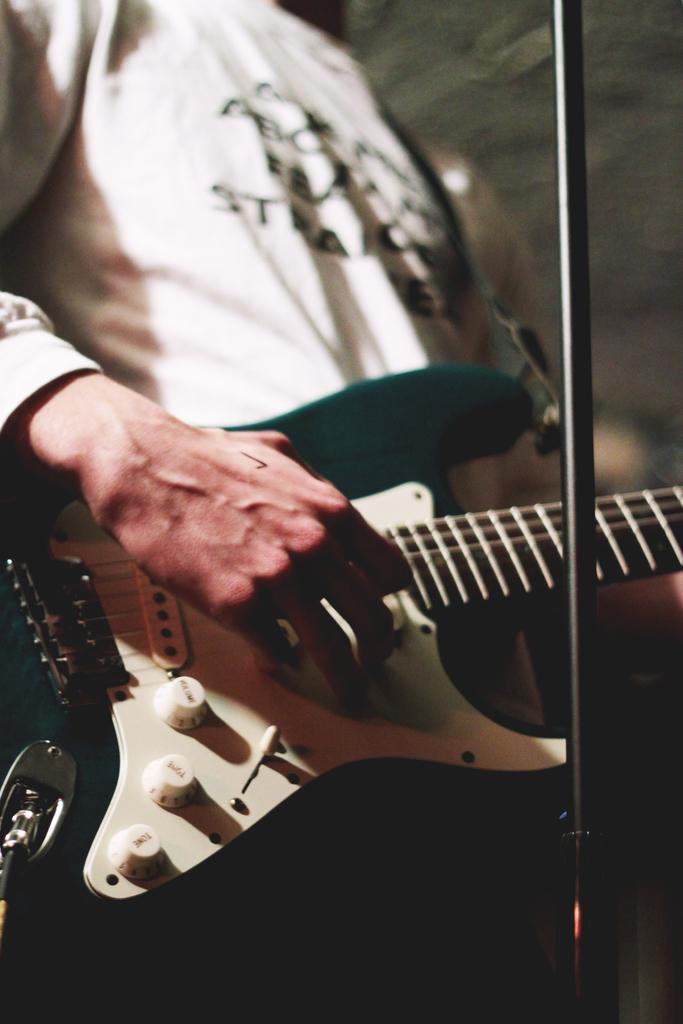What is the main subject of the image? There is a person in the image. What is the person doing in the image? The person is playing a guitar. What type of crops is the farmer growing near the harbor in the image? There is no farmer or harbor present in the image; it only features a person playing a guitar. 